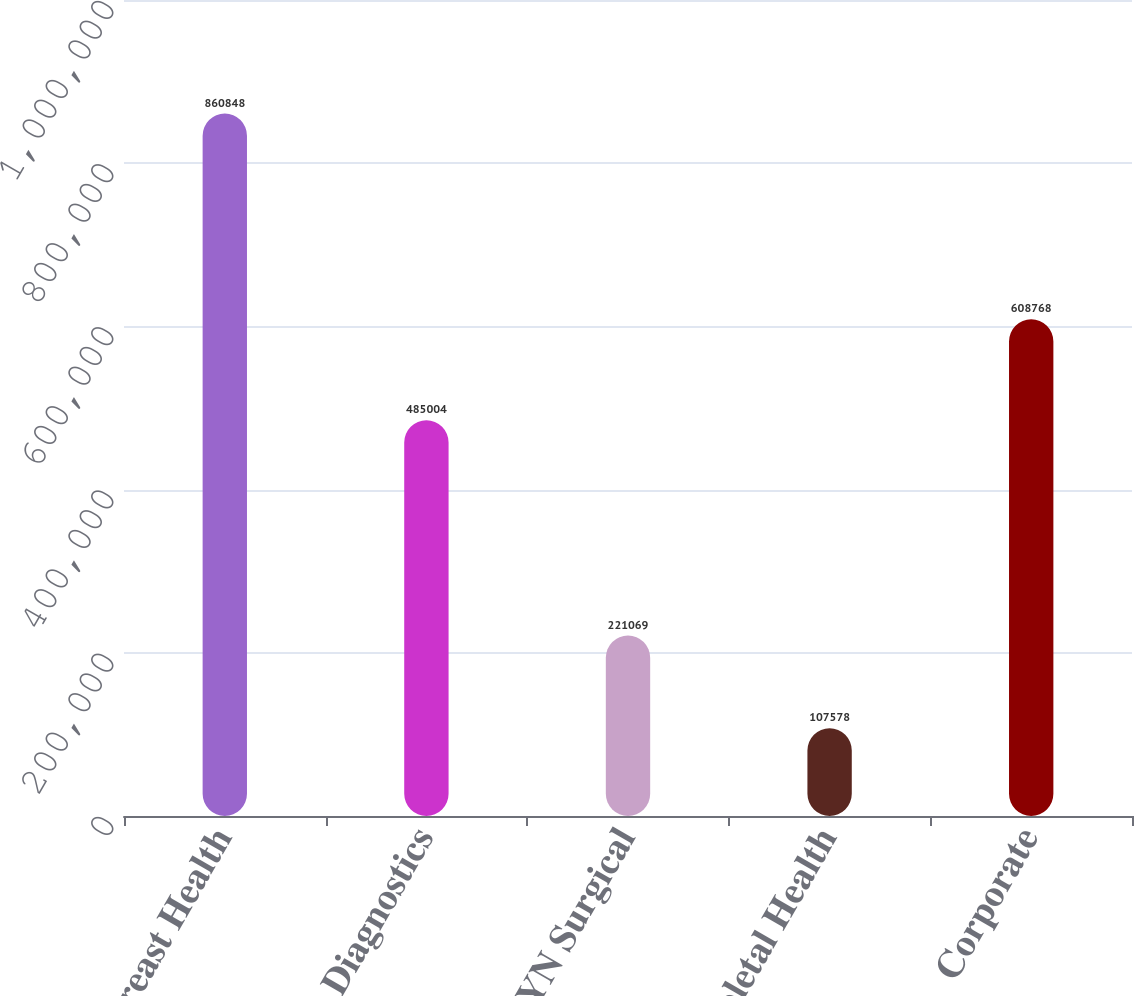Convert chart. <chart><loc_0><loc_0><loc_500><loc_500><bar_chart><fcel>Breast Health<fcel>Diagnostics<fcel>GYN Surgical<fcel>Skeletal Health<fcel>Corporate<nl><fcel>860848<fcel>485004<fcel>221069<fcel>107578<fcel>608768<nl></chart> 